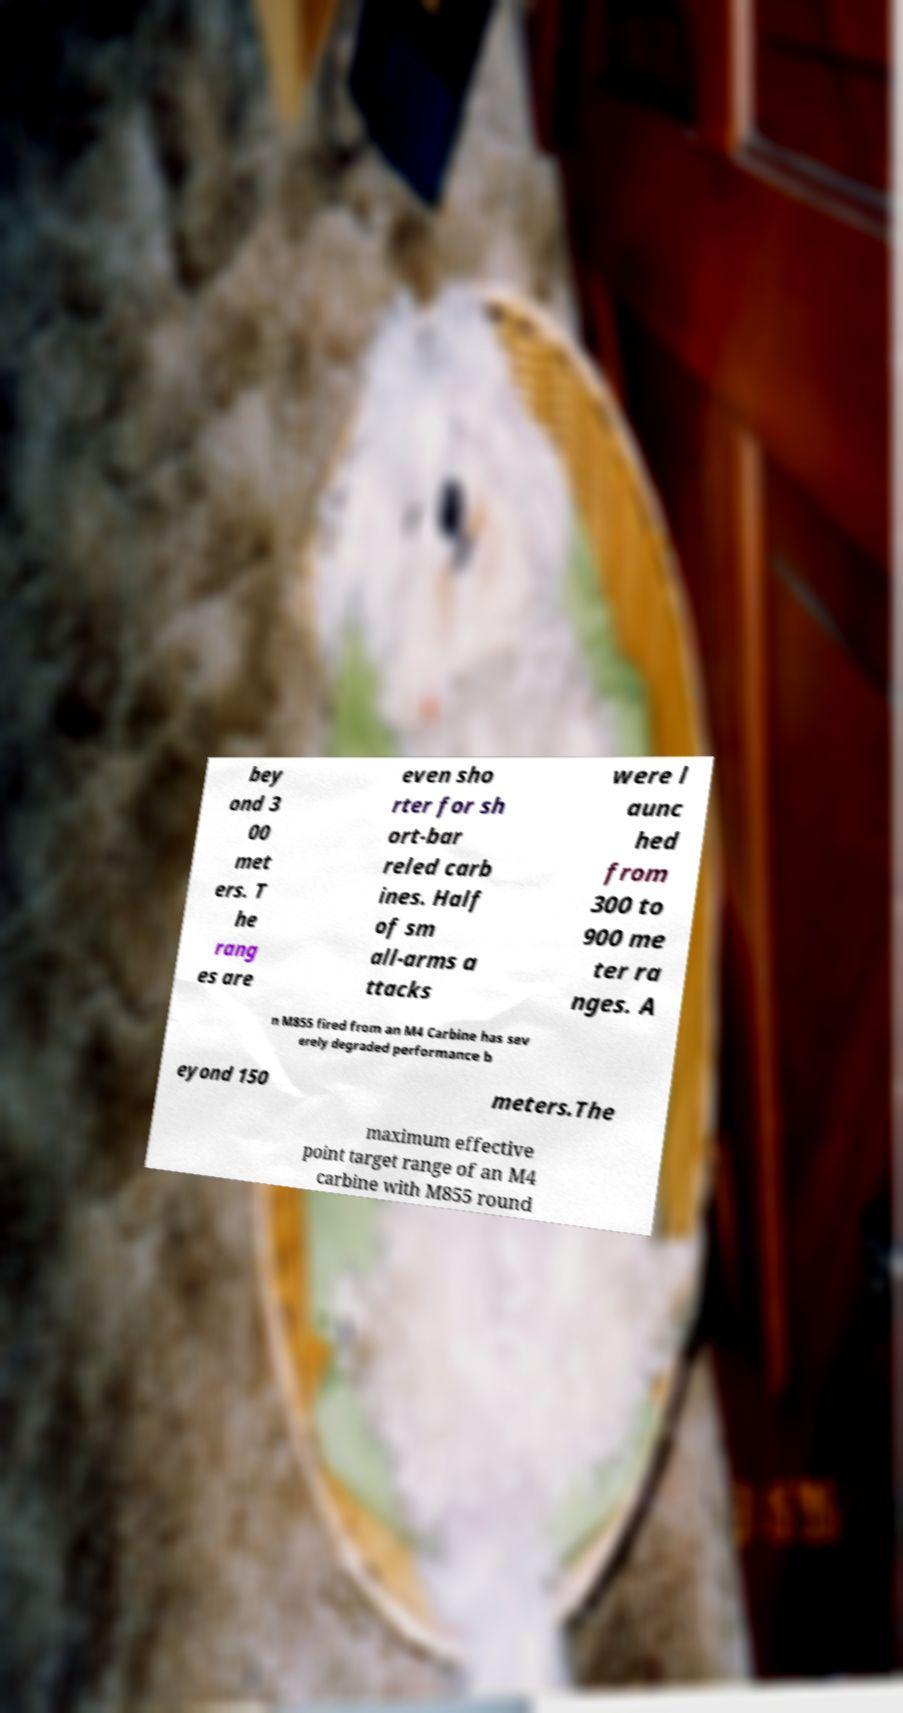For documentation purposes, I need the text within this image transcribed. Could you provide that? bey ond 3 00 met ers. T he rang es are even sho rter for sh ort-bar reled carb ines. Half of sm all-arms a ttacks were l aunc hed from 300 to 900 me ter ra nges. A n M855 fired from an M4 Carbine has sev erely degraded performance b eyond 150 meters.The maximum effective point target range of an M4 carbine with M855 round 